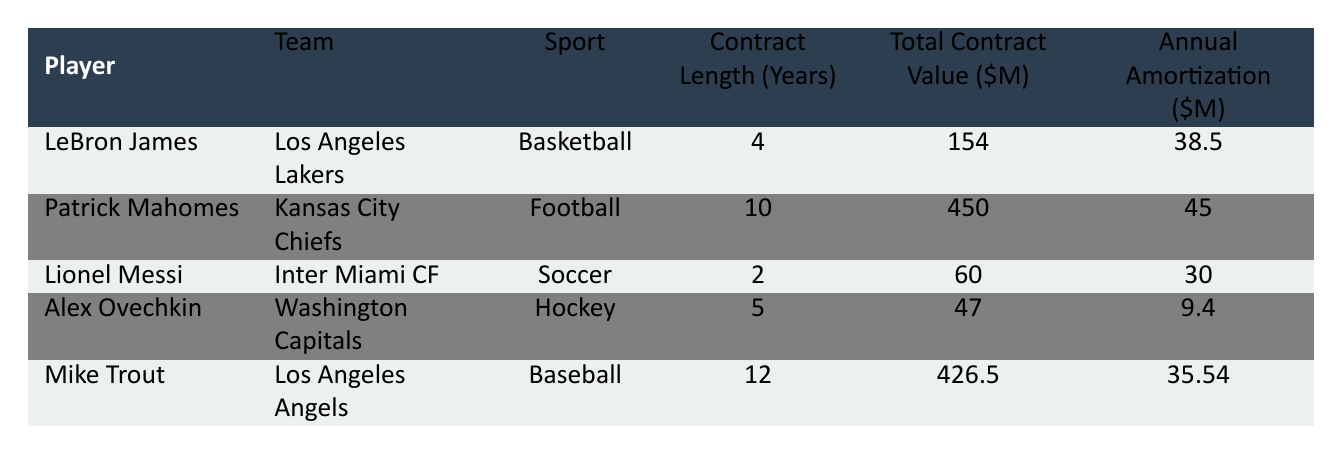What is the contract length of LeBron James? The table shows that LeBron James has a contract length of 4 years.
Answer: 4 years What is the total contract value of Patrick Mahomes? According to the table, Patrick Mahomes has a total contract value of 450 million.
Answer: 450 million Which sport has the shortest contract length in this table? The players listed with contract lengths are as follows: LeBron James (4), Patrick Mahomes (10), Lionel Messi (2), Alex Ovechkin (5), and Mike Trout (12). The shortest contract length is for Lionel Messi with 2 years.
Answer: Soccer What is the average annual amortization of the five players? The annual amortization values are 38.5, 45, 30, 9.4, and 35.54. Their sum is 38.5 + 45 + 30 + 9.4 + 35.54 = 158.44. There are 5 players, so the average is 158.44 / 5 = 31.688.
Answer: 31.688 million Is Mike Trout's contract length longer than Alex Ovechkin's? Mike Trout's contract length is 12 years, while Alex Ovechkin's is 5 years. Since 12 is greater than 5, the answer is yes.
Answer: Yes What is the difference in total contract value between LeBron James and Lionel Messi? LeBron James has a total contract value of 154 million and Lionel Messi has 60 million. The difference is 154 - 60 = 94 million.
Answer: 94 million What is the total amortization for players in the sport of Football and Basketball? The annual amortization for Patrick Mahomes (Football) is 45 million and for LeBron James (Basketball) is 38.5 million. Their total is 45 + 38.5 = 83.5 million.
Answer: 83.5 million Does any player in the table have a contract value lower than 100 million? The players with contract values in the table are LeBron James (154), Patrick Mahomes (450), Lionel Messi (60), Alex Ovechkin (47), and Mike Trout (426.5). The players with values lower than 100 million are Lionel Messi and Alex Ovechkin, so the answer is yes.
Answer: Yes How much higher is the total contract value of Mike Trout compared to Alex Ovechkin? Mike Trout's total contract value is 426.5 million and Alex Ovechkin's total contract value is 47 million. The difference is 426.5 - 47 = 379.5 million.
Answer: 379.5 million 